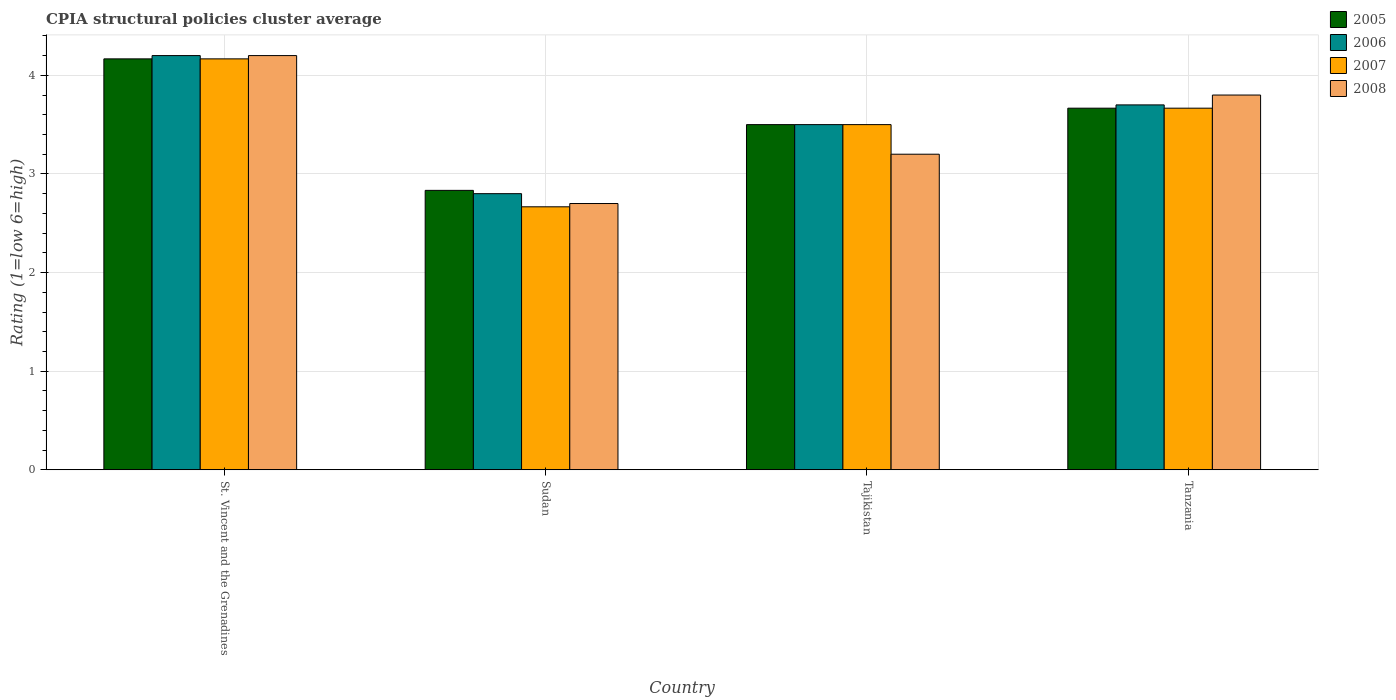Are the number of bars per tick equal to the number of legend labels?
Your response must be concise. Yes. Are the number of bars on each tick of the X-axis equal?
Give a very brief answer. Yes. How many bars are there on the 1st tick from the left?
Make the answer very short. 4. What is the label of the 1st group of bars from the left?
Offer a terse response. St. Vincent and the Grenadines. What is the CPIA rating in 2005 in Sudan?
Give a very brief answer. 2.83. Across all countries, what is the maximum CPIA rating in 2008?
Give a very brief answer. 4.2. Across all countries, what is the minimum CPIA rating in 2008?
Provide a short and direct response. 2.7. In which country was the CPIA rating in 2005 maximum?
Provide a succinct answer. St. Vincent and the Grenadines. In which country was the CPIA rating in 2006 minimum?
Your response must be concise. Sudan. What is the total CPIA rating in 2008 in the graph?
Your answer should be compact. 13.9. What is the difference between the CPIA rating in 2007 in Sudan and that in Tajikistan?
Offer a terse response. -0.83. What is the difference between the CPIA rating in 2007 in St. Vincent and the Grenadines and the CPIA rating in 2008 in Sudan?
Offer a very short reply. 1.47. What is the average CPIA rating in 2005 per country?
Provide a succinct answer. 3.54. In how many countries, is the CPIA rating in 2005 greater than 1.2?
Your response must be concise. 4. What is the ratio of the CPIA rating in 2005 in Sudan to that in Tajikistan?
Provide a succinct answer. 0.81. Is the difference between the CPIA rating in 2006 in St. Vincent and the Grenadines and Tanzania greater than the difference between the CPIA rating in 2008 in St. Vincent and the Grenadines and Tanzania?
Offer a terse response. Yes. What is the difference between the highest and the second highest CPIA rating in 2005?
Ensure brevity in your answer.  -0.17. What is the difference between the highest and the lowest CPIA rating in 2008?
Offer a terse response. 1.5. Is it the case that in every country, the sum of the CPIA rating in 2008 and CPIA rating in 2005 is greater than the sum of CPIA rating in 2007 and CPIA rating in 2006?
Provide a succinct answer. No. What does the 1st bar from the left in Tajikistan represents?
Provide a short and direct response. 2005. How many bars are there?
Your answer should be compact. 16. Are the values on the major ticks of Y-axis written in scientific E-notation?
Ensure brevity in your answer.  No. Where does the legend appear in the graph?
Ensure brevity in your answer.  Top right. How many legend labels are there?
Your response must be concise. 4. What is the title of the graph?
Your response must be concise. CPIA structural policies cluster average. Does "1966" appear as one of the legend labels in the graph?
Your answer should be compact. No. What is the label or title of the X-axis?
Make the answer very short. Country. What is the label or title of the Y-axis?
Give a very brief answer. Rating (1=low 6=high). What is the Rating (1=low 6=high) of 2005 in St. Vincent and the Grenadines?
Give a very brief answer. 4.17. What is the Rating (1=low 6=high) of 2006 in St. Vincent and the Grenadines?
Make the answer very short. 4.2. What is the Rating (1=low 6=high) in 2007 in St. Vincent and the Grenadines?
Your answer should be compact. 4.17. What is the Rating (1=low 6=high) in 2005 in Sudan?
Your answer should be compact. 2.83. What is the Rating (1=low 6=high) of 2007 in Sudan?
Make the answer very short. 2.67. What is the Rating (1=low 6=high) in 2008 in Sudan?
Ensure brevity in your answer.  2.7. What is the Rating (1=low 6=high) of 2007 in Tajikistan?
Ensure brevity in your answer.  3.5. What is the Rating (1=low 6=high) of 2008 in Tajikistan?
Your response must be concise. 3.2. What is the Rating (1=low 6=high) of 2005 in Tanzania?
Provide a short and direct response. 3.67. What is the Rating (1=low 6=high) in 2006 in Tanzania?
Keep it short and to the point. 3.7. What is the Rating (1=low 6=high) of 2007 in Tanzania?
Provide a succinct answer. 3.67. Across all countries, what is the maximum Rating (1=low 6=high) in 2005?
Your answer should be compact. 4.17. Across all countries, what is the maximum Rating (1=low 6=high) of 2007?
Provide a short and direct response. 4.17. Across all countries, what is the maximum Rating (1=low 6=high) of 2008?
Your answer should be very brief. 4.2. Across all countries, what is the minimum Rating (1=low 6=high) of 2005?
Offer a terse response. 2.83. Across all countries, what is the minimum Rating (1=low 6=high) of 2006?
Your answer should be compact. 2.8. Across all countries, what is the minimum Rating (1=low 6=high) of 2007?
Provide a succinct answer. 2.67. What is the total Rating (1=low 6=high) of 2005 in the graph?
Your answer should be very brief. 14.17. What is the total Rating (1=low 6=high) in 2006 in the graph?
Your answer should be very brief. 14.2. What is the difference between the Rating (1=low 6=high) of 2006 in St. Vincent and the Grenadines and that in Sudan?
Give a very brief answer. 1.4. What is the difference between the Rating (1=low 6=high) in 2007 in St. Vincent and the Grenadines and that in Sudan?
Give a very brief answer. 1.5. What is the difference between the Rating (1=low 6=high) in 2008 in St. Vincent and the Grenadines and that in Sudan?
Keep it short and to the point. 1.5. What is the difference between the Rating (1=low 6=high) of 2007 in St. Vincent and the Grenadines and that in Tajikistan?
Provide a short and direct response. 0.67. What is the difference between the Rating (1=low 6=high) of 2008 in St. Vincent and the Grenadines and that in Tajikistan?
Ensure brevity in your answer.  1. What is the difference between the Rating (1=low 6=high) of 2005 in St. Vincent and the Grenadines and that in Tanzania?
Provide a succinct answer. 0.5. What is the difference between the Rating (1=low 6=high) in 2007 in St. Vincent and the Grenadines and that in Tanzania?
Offer a terse response. 0.5. What is the difference between the Rating (1=low 6=high) in 2008 in St. Vincent and the Grenadines and that in Tanzania?
Provide a succinct answer. 0.4. What is the difference between the Rating (1=low 6=high) in 2006 in Sudan and that in Tajikistan?
Provide a short and direct response. -0.7. What is the difference between the Rating (1=low 6=high) in 2008 in Sudan and that in Tajikistan?
Make the answer very short. -0.5. What is the difference between the Rating (1=low 6=high) of 2006 in Sudan and that in Tanzania?
Ensure brevity in your answer.  -0.9. What is the difference between the Rating (1=low 6=high) in 2008 in Sudan and that in Tanzania?
Your answer should be compact. -1.1. What is the difference between the Rating (1=low 6=high) in 2005 in Tajikistan and that in Tanzania?
Offer a very short reply. -0.17. What is the difference between the Rating (1=low 6=high) of 2008 in Tajikistan and that in Tanzania?
Your answer should be compact. -0.6. What is the difference between the Rating (1=low 6=high) of 2005 in St. Vincent and the Grenadines and the Rating (1=low 6=high) of 2006 in Sudan?
Your answer should be compact. 1.37. What is the difference between the Rating (1=low 6=high) of 2005 in St. Vincent and the Grenadines and the Rating (1=low 6=high) of 2007 in Sudan?
Provide a short and direct response. 1.5. What is the difference between the Rating (1=low 6=high) in 2005 in St. Vincent and the Grenadines and the Rating (1=low 6=high) in 2008 in Sudan?
Offer a terse response. 1.47. What is the difference between the Rating (1=low 6=high) of 2006 in St. Vincent and the Grenadines and the Rating (1=low 6=high) of 2007 in Sudan?
Provide a short and direct response. 1.53. What is the difference between the Rating (1=low 6=high) in 2006 in St. Vincent and the Grenadines and the Rating (1=low 6=high) in 2008 in Sudan?
Offer a terse response. 1.5. What is the difference between the Rating (1=low 6=high) of 2007 in St. Vincent and the Grenadines and the Rating (1=low 6=high) of 2008 in Sudan?
Provide a short and direct response. 1.47. What is the difference between the Rating (1=low 6=high) of 2005 in St. Vincent and the Grenadines and the Rating (1=low 6=high) of 2007 in Tajikistan?
Offer a terse response. 0.67. What is the difference between the Rating (1=low 6=high) in 2005 in St. Vincent and the Grenadines and the Rating (1=low 6=high) in 2008 in Tajikistan?
Give a very brief answer. 0.97. What is the difference between the Rating (1=low 6=high) of 2007 in St. Vincent and the Grenadines and the Rating (1=low 6=high) of 2008 in Tajikistan?
Your response must be concise. 0.97. What is the difference between the Rating (1=low 6=high) of 2005 in St. Vincent and the Grenadines and the Rating (1=low 6=high) of 2006 in Tanzania?
Provide a short and direct response. 0.47. What is the difference between the Rating (1=low 6=high) of 2005 in St. Vincent and the Grenadines and the Rating (1=low 6=high) of 2007 in Tanzania?
Ensure brevity in your answer.  0.5. What is the difference between the Rating (1=low 6=high) in 2005 in St. Vincent and the Grenadines and the Rating (1=low 6=high) in 2008 in Tanzania?
Provide a short and direct response. 0.37. What is the difference between the Rating (1=low 6=high) of 2006 in St. Vincent and the Grenadines and the Rating (1=low 6=high) of 2007 in Tanzania?
Your response must be concise. 0.53. What is the difference between the Rating (1=low 6=high) in 2006 in St. Vincent and the Grenadines and the Rating (1=low 6=high) in 2008 in Tanzania?
Offer a very short reply. 0.4. What is the difference between the Rating (1=low 6=high) of 2007 in St. Vincent and the Grenadines and the Rating (1=low 6=high) of 2008 in Tanzania?
Give a very brief answer. 0.37. What is the difference between the Rating (1=low 6=high) in 2005 in Sudan and the Rating (1=low 6=high) in 2006 in Tajikistan?
Provide a short and direct response. -0.67. What is the difference between the Rating (1=low 6=high) in 2005 in Sudan and the Rating (1=low 6=high) in 2007 in Tajikistan?
Your answer should be very brief. -0.67. What is the difference between the Rating (1=low 6=high) of 2005 in Sudan and the Rating (1=low 6=high) of 2008 in Tajikistan?
Provide a short and direct response. -0.37. What is the difference between the Rating (1=low 6=high) of 2006 in Sudan and the Rating (1=low 6=high) of 2007 in Tajikistan?
Offer a terse response. -0.7. What is the difference between the Rating (1=low 6=high) in 2007 in Sudan and the Rating (1=low 6=high) in 2008 in Tajikistan?
Ensure brevity in your answer.  -0.53. What is the difference between the Rating (1=low 6=high) of 2005 in Sudan and the Rating (1=low 6=high) of 2006 in Tanzania?
Your answer should be compact. -0.87. What is the difference between the Rating (1=low 6=high) in 2005 in Sudan and the Rating (1=low 6=high) in 2007 in Tanzania?
Your response must be concise. -0.83. What is the difference between the Rating (1=low 6=high) of 2005 in Sudan and the Rating (1=low 6=high) of 2008 in Tanzania?
Offer a very short reply. -0.97. What is the difference between the Rating (1=low 6=high) in 2006 in Sudan and the Rating (1=low 6=high) in 2007 in Tanzania?
Offer a very short reply. -0.87. What is the difference between the Rating (1=low 6=high) of 2007 in Sudan and the Rating (1=low 6=high) of 2008 in Tanzania?
Offer a very short reply. -1.13. What is the difference between the Rating (1=low 6=high) in 2005 in Tajikistan and the Rating (1=low 6=high) in 2006 in Tanzania?
Provide a succinct answer. -0.2. What is the difference between the Rating (1=low 6=high) in 2005 in Tajikistan and the Rating (1=low 6=high) in 2008 in Tanzania?
Give a very brief answer. -0.3. What is the difference between the Rating (1=low 6=high) in 2006 in Tajikistan and the Rating (1=low 6=high) in 2007 in Tanzania?
Your answer should be compact. -0.17. What is the difference between the Rating (1=low 6=high) of 2007 in Tajikistan and the Rating (1=low 6=high) of 2008 in Tanzania?
Provide a short and direct response. -0.3. What is the average Rating (1=low 6=high) of 2005 per country?
Your response must be concise. 3.54. What is the average Rating (1=low 6=high) of 2006 per country?
Provide a short and direct response. 3.55. What is the average Rating (1=low 6=high) in 2008 per country?
Your response must be concise. 3.48. What is the difference between the Rating (1=low 6=high) of 2005 and Rating (1=low 6=high) of 2006 in St. Vincent and the Grenadines?
Your response must be concise. -0.03. What is the difference between the Rating (1=low 6=high) of 2005 and Rating (1=low 6=high) of 2007 in St. Vincent and the Grenadines?
Your answer should be compact. 0. What is the difference between the Rating (1=low 6=high) in 2005 and Rating (1=low 6=high) in 2008 in St. Vincent and the Grenadines?
Make the answer very short. -0.03. What is the difference between the Rating (1=low 6=high) in 2006 and Rating (1=low 6=high) in 2007 in St. Vincent and the Grenadines?
Ensure brevity in your answer.  0.03. What is the difference between the Rating (1=low 6=high) of 2007 and Rating (1=low 6=high) of 2008 in St. Vincent and the Grenadines?
Ensure brevity in your answer.  -0.03. What is the difference between the Rating (1=low 6=high) of 2005 and Rating (1=low 6=high) of 2006 in Sudan?
Your answer should be very brief. 0.03. What is the difference between the Rating (1=low 6=high) of 2005 and Rating (1=low 6=high) of 2007 in Sudan?
Offer a very short reply. 0.17. What is the difference between the Rating (1=low 6=high) of 2005 and Rating (1=low 6=high) of 2008 in Sudan?
Give a very brief answer. 0.13. What is the difference between the Rating (1=low 6=high) in 2006 and Rating (1=low 6=high) in 2007 in Sudan?
Provide a succinct answer. 0.13. What is the difference between the Rating (1=low 6=high) in 2007 and Rating (1=low 6=high) in 2008 in Sudan?
Offer a terse response. -0.03. What is the difference between the Rating (1=low 6=high) of 2005 and Rating (1=low 6=high) of 2007 in Tajikistan?
Your answer should be compact. 0. What is the difference between the Rating (1=low 6=high) of 2006 and Rating (1=low 6=high) of 2007 in Tajikistan?
Ensure brevity in your answer.  0. What is the difference between the Rating (1=low 6=high) of 2006 and Rating (1=low 6=high) of 2008 in Tajikistan?
Provide a short and direct response. 0.3. What is the difference between the Rating (1=low 6=high) of 2005 and Rating (1=low 6=high) of 2006 in Tanzania?
Give a very brief answer. -0.03. What is the difference between the Rating (1=low 6=high) in 2005 and Rating (1=low 6=high) in 2007 in Tanzania?
Your answer should be compact. 0. What is the difference between the Rating (1=low 6=high) of 2005 and Rating (1=low 6=high) of 2008 in Tanzania?
Keep it short and to the point. -0.13. What is the difference between the Rating (1=low 6=high) in 2007 and Rating (1=low 6=high) in 2008 in Tanzania?
Your response must be concise. -0.13. What is the ratio of the Rating (1=low 6=high) of 2005 in St. Vincent and the Grenadines to that in Sudan?
Provide a succinct answer. 1.47. What is the ratio of the Rating (1=low 6=high) of 2006 in St. Vincent and the Grenadines to that in Sudan?
Provide a succinct answer. 1.5. What is the ratio of the Rating (1=low 6=high) in 2007 in St. Vincent and the Grenadines to that in Sudan?
Provide a succinct answer. 1.56. What is the ratio of the Rating (1=low 6=high) in 2008 in St. Vincent and the Grenadines to that in Sudan?
Your response must be concise. 1.56. What is the ratio of the Rating (1=low 6=high) of 2005 in St. Vincent and the Grenadines to that in Tajikistan?
Provide a short and direct response. 1.19. What is the ratio of the Rating (1=low 6=high) in 2006 in St. Vincent and the Grenadines to that in Tajikistan?
Give a very brief answer. 1.2. What is the ratio of the Rating (1=low 6=high) in 2007 in St. Vincent and the Grenadines to that in Tajikistan?
Offer a very short reply. 1.19. What is the ratio of the Rating (1=low 6=high) in 2008 in St. Vincent and the Grenadines to that in Tajikistan?
Provide a short and direct response. 1.31. What is the ratio of the Rating (1=low 6=high) in 2005 in St. Vincent and the Grenadines to that in Tanzania?
Give a very brief answer. 1.14. What is the ratio of the Rating (1=low 6=high) in 2006 in St. Vincent and the Grenadines to that in Tanzania?
Provide a succinct answer. 1.14. What is the ratio of the Rating (1=low 6=high) in 2007 in St. Vincent and the Grenadines to that in Tanzania?
Offer a very short reply. 1.14. What is the ratio of the Rating (1=low 6=high) of 2008 in St. Vincent and the Grenadines to that in Tanzania?
Ensure brevity in your answer.  1.11. What is the ratio of the Rating (1=low 6=high) of 2005 in Sudan to that in Tajikistan?
Provide a succinct answer. 0.81. What is the ratio of the Rating (1=low 6=high) in 2006 in Sudan to that in Tajikistan?
Give a very brief answer. 0.8. What is the ratio of the Rating (1=low 6=high) of 2007 in Sudan to that in Tajikistan?
Offer a terse response. 0.76. What is the ratio of the Rating (1=low 6=high) in 2008 in Sudan to that in Tajikistan?
Provide a short and direct response. 0.84. What is the ratio of the Rating (1=low 6=high) of 2005 in Sudan to that in Tanzania?
Keep it short and to the point. 0.77. What is the ratio of the Rating (1=low 6=high) of 2006 in Sudan to that in Tanzania?
Make the answer very short. 0.76. What is the ratio of the Rating (1=low 6=high) in 2007 in Sudan to that in Tanzania?
Ensure brevity in your answer.  0.73. What is the ratio of the Rating (1=low 6=high) in 2008 in Sudan to that in Tanzania?
Provide a succinct answer. 0.71. What is the ratio of the Rating (1=low 6=high) in 2005 in Tajikistan to that in Tanzania?
Provide a short and direct response. 0.95. What is the ratio of the Rating (1=low 6=high) of 2006 in Tajikistan to that in Tanzania?
Keep it short and to the point. 0.95. What is the ratio of the Rating (1=low 6=high) of 2007 in Tajikistan to that in Tanzania?
Your answer should be very brief. 0.95. What is the ratio of the Rating (1=low 6=high) of 2008 in Tajikistan to that in Tanzania?
Offer a terse response. 0.84. What is the difference between the highest and the second highest Rating (1=low 6=high) of 2008?
Your answer should be very brief. 0.4. What is the difference between the highest and the lowest Rating (1=low 6=high) in 2005?
Offer a terse response. 1.33. What is the difference between the highest and the lowest Rating (1=low 6=high) of 2006?
Offer a very short reply. 1.4. 